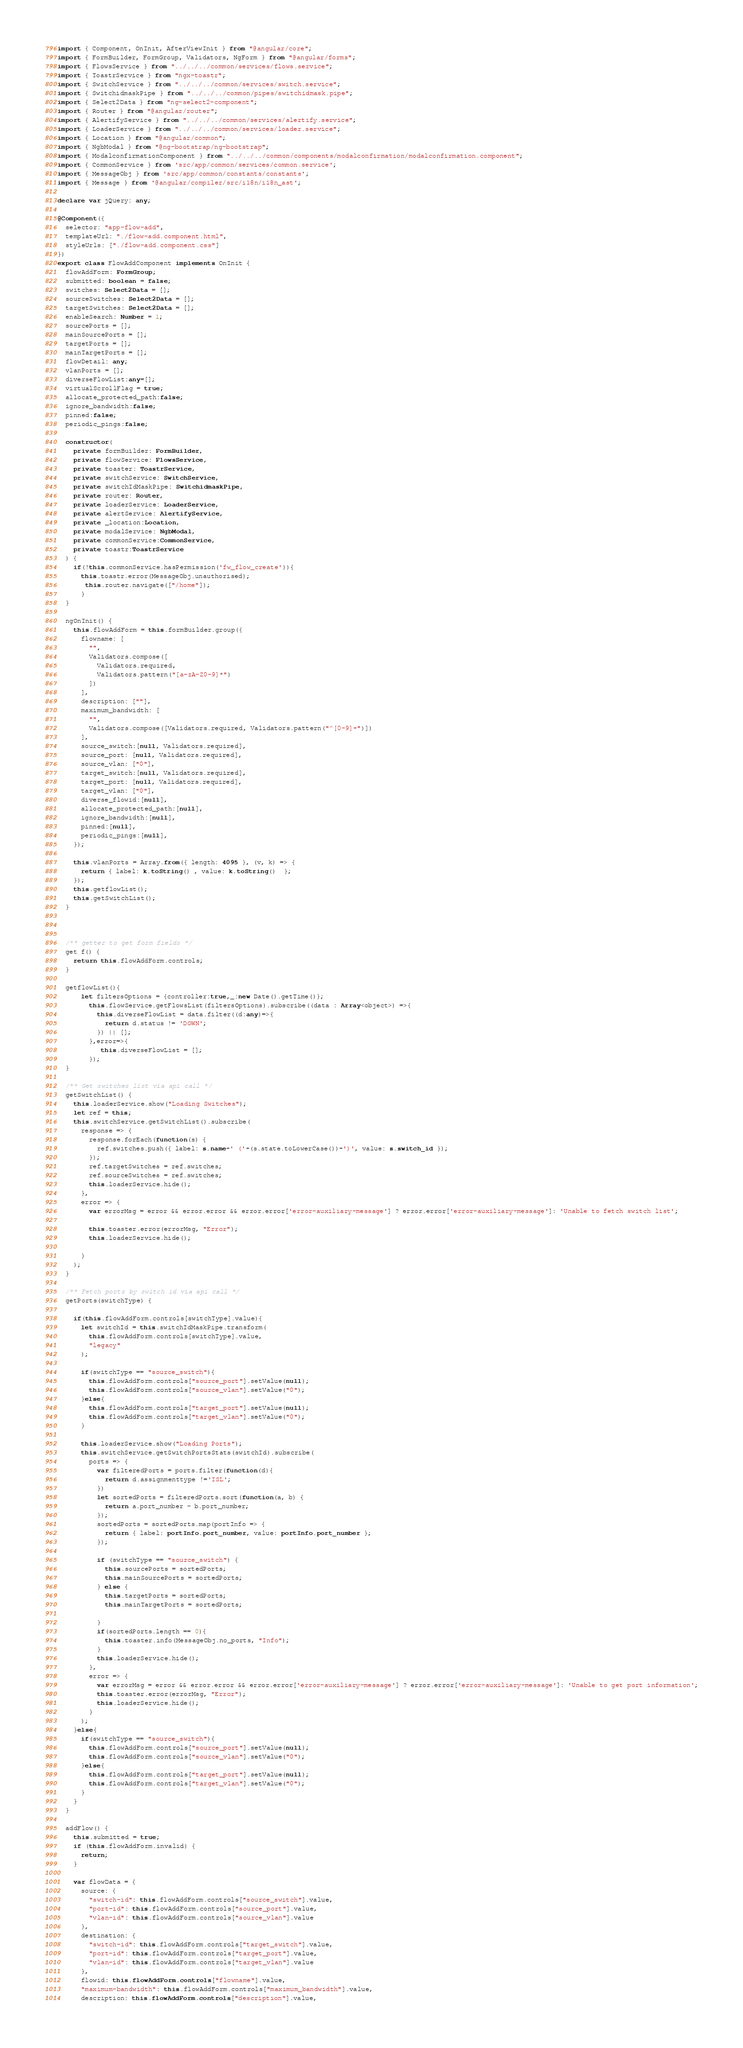Convert code to text. <code><loc_0><loc_0><loc_500><loc_500><_TypeScript_>import { Component, OnInit, AfterViewInit } from "@angular/core";
import { FormBuilder, FormGroup, Validators, NgForm } from "@angular/forms";
import { FlowsService } from "../../../common/services/flows.service";
import { ToastrService } from "ngx-toastr";
import { SwitchService } from "../../../common/services/switch.service";
import { SwitchidmaskPipe } from "../../../common/pipes/switchidmask.pipe";
import { Select2Data } from "ng-select2-component";
import { Router } from "@angular/router";
import { AlertifyService } from "../../../common/services/alertify.service";
import { LoaderService } from "../../../common/services/loader.service";
import { Location } from "@angular/common";
import { NgbModal } from "@ng-bootstrap/ng-bootstrap";
import { ModalconfirmationComponent } from "../../../common/components/modalconfirmation/modalconfirmation.component";
import { CommonService } from 'src/app/common/services/common.service';
import { MessageObj } from 'src/app/common/constants/constants';
import { Message } from '@angular/compiler/src/i18n/i18n_ast';

declare var jQuery: any;

@Component({
  selector: "app-flow-add",
  templateUrl: "./flow-add.component.html",
  styleUrls: ["./flow-add.component.css"]
})
export class FlowAddComponent implements OnInit {
  flowAddForm: FormGroup;
  submitted: boolean = false;
  switches: Select2Data = [];
  sourceSwitches: Select2Data = [];
  targetSwitches: Select2Data = [];
  enableSearch: Number = 1;
  sourcePorts = [];
  mainSourcePorts = [];
  targetPorts = [];
  mainTargetPorts = [];
  flowDetail: any;
  vlanPorts = [];
  diverseFlowList:any=[];
  virtualScrollFlag = true;
  allocate_protected_path:false;
  ignore_bandwidth:false;
  pinned:false;
  periodic_pings:false;

  constructor(
    private formBuilder: FormBuilder,
    private flowService: FlowsService,
    private toaster: ToastrService,
    private switchService: SwitchService,
    private switchIdMaskPipe: SwitchidmaskPipe,
    private router: Router,
    private loaderService: LoaderService,
    private alertService: AlertifyService,
    private _location:Location,
    private modalService: NgbModal,
    private commonService:CommonService,
    private toastr:ToastrService
  ) {
    if(!this.commonService.hasPermission('fw_flow_create')){
      this.toastr.error(MessageObj.unauthorised);  
       this.router.navigate(["/home"]);
      }
  }

  ngOnInit() {
    this.flowAddForm = this.formBuilder.group({
      flowname: [
        "",
        Validators.compose([
          Validators.required,
          Validators.pattern("[a-zA-Z0-9]*")
        ])
      ],
      description: [""],
      maximum_bandwidth: [
        "",
        Validators.compose([Validators.required, Validators.pattern("^[0-9]+")])
      ],
      source_switch:[null, Validators.required],
      source_port: [null, Validators.required],
      source_vlan: ["0"],
      target_switch:[null, Validators.required],
      target_port: [null, Validators.required],
      target_vlan: ["0"],
      diverse_flowid:[null],
      allocate_protected_path:[null],
      ignore_bandwidth:[null],
      pinned:[null],
      periodic_pings:[null],
    });

    this.vlanPorts = Array.from({ length: 4095 }, (v, k) => {
      return { label: k.toString() , value: k.toString()  };
    });
    this.getflowList();
    this.getSwitchList();
  }

 

  /** getter to get form fields */
  get f() {
    return this.flowAddForm.controls;
  }

  getflowList(){
      let filtersOptions = {controller:true,_:new Date().getTime()};
        this.flowService.getFlowsList(filtersOptions).subscribe((data : Array<object>) =>{
          this.diverseFlowList = data.filter((d:any)=>{
            return d.status != 'DOWN';
          }) || [];
        },error=>{
           this.diverseFlowList = [];  
        });
  }

  /** Get switches list via api call */
  getSwitchList() {
    this.loaderService.show("Loading Switches");
    let ref = this;
    this.switchService.getSwitchList().subscribe(
      response => {
        response.forEach(function(s) { 
          ref.switches.push({ label: s.name+' ('+(s.state.toLowerCase())+')', value: s.switch_id });
        });
        ref.targetSwitches = ref.switches;
        ref.sourceSwitches = ref.switches;
        this.loaderService.hide();
      },
      error => {
        var errorMsg = error && error.error && error.error['error-auxiliary-message'] ? error.error['error-auxiliary-message']: 'Unable to fetch switch list';
       
        this.toaster.error(errorMsg, "Error");
        this.loaderService.hide();

      }
    );
  }

  /** Fetch ports by switch id via api call */
  getPorts(switchType) {
    
    if(this.flowAddForm.controls[switchType].value){
      let switchId = this.switchIdMaskPipe.transform(
        this.flowAddForm.controls[switchType].value,
        "legacy"
      );

      if(switchType == "source_switch"){ 
        this.flowAddForm.controls["source_port"].setValue(null);
        this.flowAddForm.controls["source_vlan"].setValue("0");
      }else{
        this.flowAddForm.controls["target_port"].setValue(null);
        this.flowAddForm.controls["target_vlan"].setValue("0");
      } 

      this.loaderService.show("Loading Ports");
      this.switchService.getSwitchPortsStats(switchId).subscribe(
        ports => {
          var filteredPorts = ports.filter(function(d){
            return d.assignmenttype !='ISL';
          })
          let sortedPorts = filteredPorts.sort(function(a, b) {
            return a.port_number - b.port_number;
          });
          sortedPorts = sortedPorts.map(portInfo => {
            return { label: portInfo.port_number, value: portInfo.port_number };
          });

          if (switchType == "source_switch") {
            this.sourcePorts = sortedPorts;
            this.mainSourcePorts = sortedPorts;
          } else {
            this.targetPorts = sortedPorts;
            this.mainTargetPorts = sortedPorts; 
            
          }
          if(sortedPorts.length == 0){
            this.toaster.info(MessageObj.no_ports, "Info");
          }
          this.loaderService.hide();
        },
        error => {
          var errorMsg = error && error.error && error.error['error-auxiliary-message'] ? error.error['error-auxiliary-message']: 'Unable to get port information';
          this.toaster.error(errorMsg, "Error");
          this.loaderService.hide();
        }
      );
    }else{
      if(switchType == "source_switch"){ 
        this.flowAddForm.controls["source_port"].setValue(null);
        this.flowAddForm.controls["source_vlan"].setValue("0");
      }else{
        this.flowAddForm.controls["target_port"].setValue(null);
        this.flowAddForm.controls["target_vlan"].setValue("0");
      } 
    }
  }

  addFlow() {
    this.submitted = true;
    if (this.flowAddForm.invalid) {
      return;
    }

    var flowData = {
      source: {
        "switch-id": this.flowAddForm.controls["source_switch"].value,
        "port-id": this.flowAddForm.controls["source_port"].value,
        "vlan-id": this.flowAddForm.controls["source_vlan"].value
      },
      destination: {
        "switch-id": this.flowAddForm.controls["target_switch"].value,
        "port-id": this.flowAddForm.controls["target_port"].value,
        "vlan-id": this.flowAddForm.controls["target_vlan"].value
      },
      flowid: this.flowAddForm.controls["flowname"].value,
      "maximum-bandwidth": this.flowAddForm.controls["maximum_bandwidth"].value,
      description: this.flowAddForm.controls["description"].value,</code> 